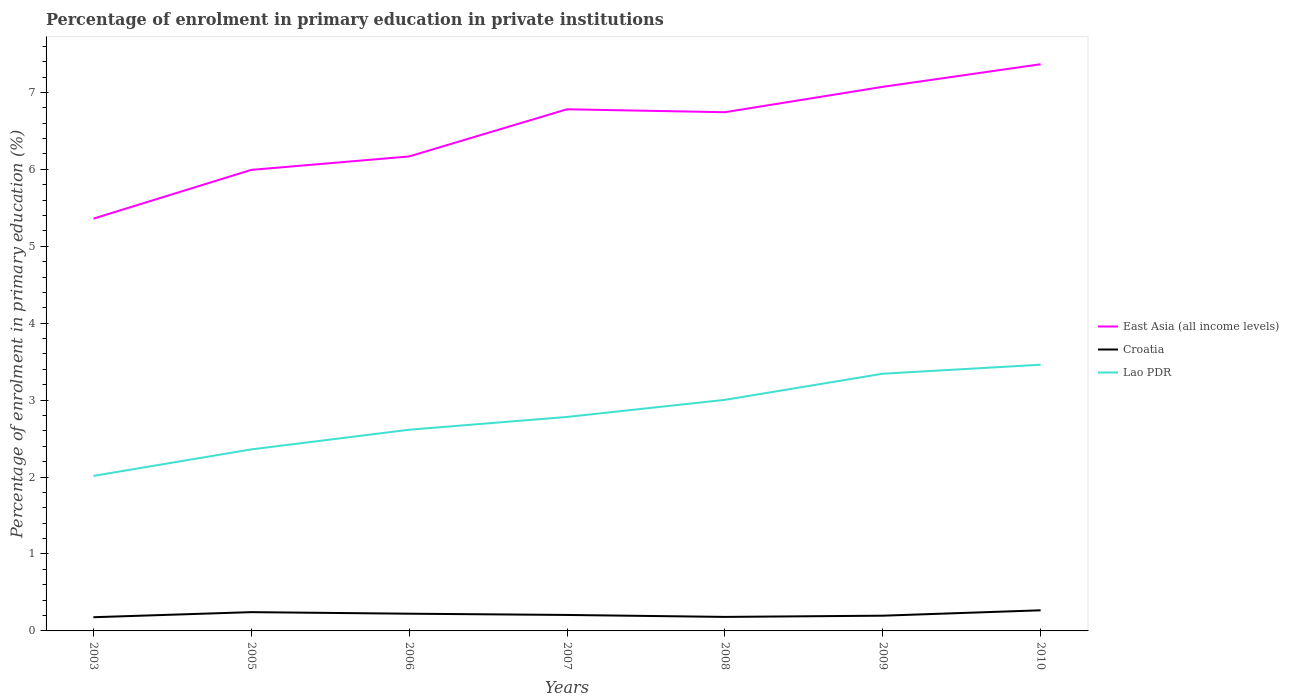How many different coloured lines are there?
Ensure brevity in your answer.  3. Is the number of lines equal to the number of legend labels?
Your answer should be very brief. Yes. Across all years, what is the maximum percentage of enrolment in primary education in East Asia (all income levels)?
Offer a terse response. 5.36. In which year was the percentage of enrolment in primary education in Lao PDR maximum?
Your response must be concise. 2003. What is the total percentage of enrolment in primary education in Croatia in the graph?
Provide a short and direct response. -0. What is the difference between the highest and the second highest percentage of enrolment in primary education in Croatia?
Your answer should be compact. 0.09. How many years are there in the graph?
Provide a succinct answer. 7. Does the graph contain any zero values?
Offer a very short reply. No. Does the graph contain grids?
Your answer should be compact. No. Where does the legend appear in the graph?
Provide a succinct answer. Center right. How are the legend labels stacked?
Your answer should be compact. Vertical. What is the title of the graph?
Offer a terse response. Percentage of enrolment in primary education in private institutions. Does "Middle income" appear as one of the legend labels in the graph?
Give a very brief answer. No. What is the label or title of the Y-axis?
Your response must be concise. Percentage of enrolment in primary education (%). What is the Percentage of enrolment in primary education (%) in East Asia (all income levels) in 2003?
Give a very brief answer. 5.36. What is the Percentage of enrolment in primary education (%) in Croatia in 2003?
Provide a succinct answer. 0.18. What is the Percentage of enrolment in primary education (%) in Lao PDR in 2003?
Your response must be concise. 2.02. What is the Percentage of enrolment in primary education (%) of East Asia (all income levels) in 2005?
Your response must be concise. 5.99. What is the Percentage of enrolment in primary education (%) of Croatia in 2005?
Ensure brevity in your answer.  0.24. What is the Percentage of enrolment in primary education (%) of Lao PDR in 2005?
Give a very brief answer. 2.36. What is the Percentage of enrolment in primary education (%) in East Asia (all income levels) in 2006?
Give a very brief answer. 6.17. What is the Percentage of enrolment in primary education (%) in Croatia in 2006?
Offer a very short reply. 0.22. What is the Percentage of enrolment in primary education (%) in Lao PDR in 2006?
Offer a terse response. 2.62. What is the Percentage of enrolment in primary education (%) of East Asia (all income levels) in 2007?
Keep it short and to the point. 6.78. What is the Percentage of enrolment in primary education (%) of Croatia in 2007?
Provide a succinct answer. 0.21. What is the Percentage of enrolment in primary education (%) of Lao PDR in 2007?
Ensure brevity in your answer.  2.78. What is the Percentage of enrolment in primary education (%) of East Asia (all income levels) in 2008?
Provide a short and direct response. 6.74. What is the Percentage of enrolment in primary education (%) in Croatia in 2008?
Your answer should be compact. 0.18. What is the Percentage of enrolment in primary education (%) in Lao PDR in 2008?
Offer a very short reply. 3. What is the Percentage of enrolment in primary education (%) of East Asia (all income levels) in 2009?
Your answer should be very brief. 7.07. What is the Percentage of enrolment in primary education (%) of Croatia in 2009?
Offer a very short reply. 0.2. What is the Percentage of enrolment in primary education (%) of Lao PDR in 2009?
Make the answer very short. 3.34. What is the Percentage of enrolment in primary education (%) of East Asia (all income levels) in 2010?
Ensure brevity in your answer.  7.37. What is the Percentage of enrolment in primary education (%) of Croatia in 2010?
Provide a short and direct response. 0.27. What is the Percentage of enrolment in primary education (%) of Lao PDR in 2010?
Make the answer very short. 3.46. Across all years, what is the maximum Percentage of enrolment in primary education (%) in East Asia (all income levels)?
Your answer should be very brief. 7.37. Across all years, what is the maximum Percentage of enrolment in primary education (%) of Croatia?
Ensure brevity in your answer.  0.27. Across all years, what is the maximum Percentage of enrolment in primary education (%) in Lao PDR?
Your answer should be compact. 3.46. Across all years, what is the minimum Percentage of enrolment in primary education (%) of East Asia (all income levels)?
Offer a terse response. 5.36. Across all years, what is the minimum Percentage of enrolment in primary education (%) in Croatia?
Provide a short and direct response. 0.18. Across all years, what is the minimum Percentage of enrolment in primary education (%) in Lao PDR?
Ensure brevity in your answer.  2.02. What is the total Percentage of enrolment in primary education (%) in East Asia (all income levels) in the graph?
Your answer should be very brief. 45.48. What is the total Percentage of enrolment in primary education (%) of Croatia in the graph?
Provide a short and direct response. 1.5. What is the total Percentage of enrolment in primary education (%) of Lao PDR in the graph?
Provide a succinct answer. 19.58. What is the difference between the Percentage of enrolment in primary education (%) of East Asia (all income levels) in 2003 and that in 2005?
Provide a short and direct response. -0.63. What is the difference between the Percentage of enrolment in primary education (%) in Croatia in 2003 and that in 2005?
Your answer should be compact. -0.07. What is the difference between the Percentage of enrolment in primary education (%) in Lao PDR in 2003 and that in 2005?
Your response must be concise. -0.34. What is the difference between the Percentage of enrolment in primary education (%) of East Asia (all income levels) in 2003 and that in 2006?
Provide a succinct answer. -0.81. What is the difference between the Percentage of enrolment in primary education (%) of Croatia in 2003 and that in 2006?
Provide a short and direct response. -0.05. What is the difference between the Percentage of enrolment in primary education (%) in Lao PDR in 2003 and that in 2006?
Your response must be concise. -0.6. What is the difference between the Percentage of enrolment in primary education (%) in East Asia (all income levels) in 2003 and that in 2007?
Keep it short and to the point. -1.42. What is the difference between the Percentage of enrolment in primary education (%) of Croatia in 2003 and that in 2007?
Provide a succinct answer. -0.03. What is the difference between the Percentage of enrolment in primary education (%) in Lao PDR in 2003 and that in 2007?
Your response must be concise. -0.77. What is the difference between the Percentage of enrolment in primary education (%) of East Asia (all income levels) in 2003 and that in 2008?
Keep it short and to the point. -1.38. What is the difference between the Percentage of enrolment in primary education (%) in Croatia in 2003 and that in 2008?
Keep it short and to the point. -0. What is the difference between the Percentage of enrolment in primary education (%) in Lao PDR in 2003 and that in 2008?
Offer a very short reply. -0.99. What is the difference between the Percentage of enrolment in primary education (%) in East Asia (all income levels) in 2003 and that in 2009?
Provide a short and direct response. -1.71. What is the difference between the Percentage of enrolment in primary education (%) in Croatia in 2003 and that in 2009?
Make the answer very short. -0.02. What is the difference between the Percentage of enrolment in primary education (%) in Lao PDR in 2003 and that in 2009?
Your answer should be compact. -1.33. What is the difference between the Percentage of enrolment in primary education (%) of East Asia (all income levels) in 2003 and that in 2010?
Make the answer very short. -2.01. What is the difference between the Percentage of enrolment in primary education (%) in Croatia in 2003 and that in 2010?
Provide a short and direct response. -0.09. What is the difference between the Percentage of enrolment in primary education (%) of Lao PDR in 2003 and that in 2010?
Ensure brevity in your answer.  -1.45. What is the difference between the Percentage of enrolment in primary education (%) in East Asia (all income levels) in 2005 and that in 2006?
Offer a very short reply. -0.17. What is the difference between the Percentage of enrolment in primary education (%) of Croatia in 2005 and that in 2006?
Your response must be concise. 0.02. What is the difference between the Percentage of enrolment in primary education (%) in Lao PDR in 2005 and that in 2006?
Give a very brief answer. -0.26. What is the difference between the Percentage of enrolment in primary education (%) of East Asia (all income levels) in 2005 and that in 2007?
Your response must be concise. -0.79. What is the difference between the Percentage of enrolment in primary education (%) of Croatia in 2005 and that in 2007?
Provide a short and direct response. 0.04. What is the difference between the Percentage of enrolment in primary education (%) of Lao PDR in 2005 and that in 2007?
Your answer should be very brief. -0.42. What is the difference between the Percentage of enrolment in primary education (%) of East Asia (all income levels) in 2005 and that in 2008?
Your response must be concise. -0.75. What is the difference between the Percentage of enrolment in primary education (%) in Croatia in 2005 and that in 2008?
Provide a short and direct response. 0.06. What is the difference between the Percentage of enrolment in primary education (%) in Lao PDR in 2005 and that in 2008?
Your response must be concise. -0.64. What is the difference between the Percentage of enrolment in primary education (%) of East Asia (all income levels) in 2005 and that in 2009?
Offer a very short reply. -1.08. What is the difference between the Percentage of enrolment in primary education (%) in Croatia in 2005 and that in 2009?
Offer a very short reply. 0.05. What is the difference between the Percentage of enrolment in primary education (%) in Lao PDR in 2005 and that in 2009?
Offer a very short reply. -0.98. What is the difference between the Percentage of enrolment in primary education (%) of East Asia (all income levels) in 2005 and that in 2010?
Offer a very short reply. -1.37. What is the difference between the Percentage of enrolment in primary education (%) in Croatia in 2005 and that in 2010?
Make the answer very short. -0.02. What is the difference between the Percentage of enrolment in primary education (%) of Lao PDR in 2005 and that in 2010?
Your answer should be very brief. -1.1. What is the difference between the Percentage of enrolment in primary education (%) of East Asia (all income levels) in 2006 and that in 2007?
Offer a very short reply. -0.61. What is the difference between the Percentage of enrolment in primary education (%) in Croatia in 2006 and that in 2007?
Give a very brief answer. 0.02. What is the difference between the Percentage of enrolment in primary education (%) of Lao PDR in 2006 and that in 2007?
Provide a short and direct response. -0.17. What is the difference between the Percentage of enrolment in primary education (%) in East Asia (all income levels) in 2006 and that in 2008?
Offer a terse response. -0.57. What is the difference between the Percentage of enrolment in primary education (%) in Croatia in 2006 and that in 2008?
Provide a succinct answer. 0.04. What is the difference between the Percentage of enrolment in primary education (%) of Lao PDR in 2006 and that in 2008?
Offer a terse response. -0.39. What is the difference between the Percentage of enrolment in primary education (%) of East Asia (all income levels) in 2006 and that in 2009?
Make the answer very short. -0.91. What is the difference between the Percentage of enrolment in primary education (%) of Croatia in 2006 and that in 2009?
Your answer should be compact. 0.03. What is the difference between the Percentage of enrolment in primary education (%) in Lao PDR in 2006 and that in 2009?
Offer a very short reply. -0.73. What is the difference between the Percentage of enrolment in primary education (%) in East Asia (all income levels) in 2006 and that in 2010?
Give a very brief answer. -1.2. What is the difference between the Percentage of enrolment in primary education (%) in Croatia in 2006 and that in 2010?
Make the answer very short. -0.04. What is the difference between the Percentage of enrolment in primary education (%) in Lao PDR in 2006 and that in 2010?
Offer a terse response. -0.84. What is the difference between the Percentage of enrolment in primary education (%) of East Asia (all income levels) in 2007 and that in 2008?
Your answer should be very brief. 0.04. What is the difference between the Percentage of enrolment in primary education (%) of Croatia in 2007 and that in 2008?
Offer a terse response. 0.03. What is the difference between the Percentage of enrolment in primary education (%) of Lao PDR in 2007 and that in 2008?
Your answer should be very brief. -0.22. What is the difference between the Percentage of enrolment in primary education (%) of East Asia (all income levels) in 2007 and that in 2009?
Offer a terse response. -0.29. What is the difference between the Percentage of enrolment in primary education (%) of Croatia in 2007 and that in 2009?
Your response must be concise. 0.01. What is the difference between the Percentage of enrolment in primary education (%) in Lao PDR in 2007 and that in 2009?
Your answer should be very brief. -0.56. What is the difference between the Percentage of enrolment in primary education (%) of East Asia (all income levels) in 2007 and that in 2010?
Ensure brevity in your answer.  -0.59. What is the difference between the Percentage of enrolment in primary education (%) of Croatia in 2007 and that in 2010?
Ensure brevity in your answer.  -0.06. What is the difference between the Percentage of enrolment in primary education (%) of Lao PDR in 2007 and that in 2010?
Ensure brevity in your answer.  -0.68. What is the difference between the Percentage of enrolment in primary education (%) in East Asia (all income levels) in 2008 and that in 2009?
Give a very brief answer. -0.33. What is the difference between the Percentage of enrolment in primary education (%) in Croatia in 2008 and that in 2009?
Make the answer very short. -0.02. What is the difference between the Percentage of enrolment in primary education (%) in Lao PDR in 2008 and that in 2009?
Offer a very short reply. -0.34. What is the difference between the Percentage of enrolment in primary education (%) of East Asia (all income levels) in 2008 and that in 2010?
Provide a short and direct response. -0.62. What is the difference between the Percentage of enrolment in primary education (%) of Croatia in 2008 and that in 2010?
Give a very brief answer. -0.09. What is the difference between the Percentage of enrolment in primary education (%) of Lao PDR in 2008 and that in 2010?
Ensure brevity in your answer.  -0.46. What is the difference between the Percentage of enrolment in primary education (%) of East Asia (all income levels) in 2009 and that in 2010?
Your answer should be very brief. -0.29. What is the difference between the Percentage of enrolment in primary education (%) in Croatia in 2009 and that in 2010?
Ensure brevity in your answer.  -0.07. What is the difference between the Percentage of enrolment in primary education (%) of Lao PDR in 2009 and that in 2010?
Make the answer very short. -0.12. What is the difference between the Percentage of enrolment in primary education (%) in East Asia (all income levels) in 2003 and the Percentage of enrolment in primary education (%) in Croatia in 2005?
Your answer should be compact. 5.12. What is the difference between the Percentage of enrolment in primary education (%) in East Asia (all income levels) in 2003 and the Percentage of enrolment in primary education (%) in Lao PDR in 2005?
Provide a short and direct response. 3. What is the difference between the Percentage of enrolment in primary education (%) in Croatia in 2003 and the Percentage of enrolment in primary education (%) in Lao PDR in 2005?
Make the answer very short. -2.18. What is the difference between the Percentage of enrolment in primary education (%) of East Asia (all income levels) in 2003 and the Percentage of enrolment in primary education (%) of Croatia in 2006?
Make the answer very short. 5.14. What is the difference between the Percentage of enrolment in primary education (%) in East Asia (all income levels) in 2003 and the Percentage of enrolment in primary education (%) in Lao PDR in 2006?
Your answer should be very brief. 2.74. What is the difference between the Percentage of enrolment in primary education (%) of Croatia in 2003 and the Percentage of enrolment in primary education (%) of Lao PDR in 2006?
Keep it short and to the point. -2.44. What is the difference between the Percentage of enrolment in primary education (%) of East Asia (all income levels) in 2003 and the Percentage of enrolment in primary education (%) of Croatia in 2007?
Offer a terse response. 5.15. What is the difference between the Percentage of enrolment in primary education (%) in East Asia (all income levels) in 2003 and the Percentage of enrolment in primary education (%) in Lao PDR in 2007?
Your answer should be very brief. 2.58. What is the difference between the Percentage of enrolment in primary education (%) in Croatia in 2003 and the Percentage of enrolment in primary education (%) in Lao PDR in 2007?
Offer a very short reply. -2.6. What is the difference between the Percentage of enrolment in primary education (%) of East Asia (all income levels) in 2003 and the Percentage of enrolment in primary education (%) of Croatia in 2008?
Give a very brief answer. 5.18. What is the difference between the Percentage of enrolment in primary education (%) in East Asia (all income levels) in 2003 and the Percentage of enrolment in primary education (%) in Lao PDR in 2008?
Make the answer very short. 2.36. What is the difference between the Percentage of enrolment in primary education (%) in Croatia in 2003 and the Percentage of enrolment in primary education (%) in Lao PDR in 2008?
Keep it short and to the point. -2.83. What is the difference between the Percentage of enrolment in primary education (%) in East Asia (all income levels) in 2003 and the Percentage of enrolment in primary education (%) in Croatia in 2009?
Give a very brief answer. 5.16. What is the difference between the Percentage of enrolment in primary education (%) of East Asia (all income levels) in 2003 and the Percentage of enrolment in primary education (%) of Lao PDR in 2009?
Make the answer very short. 2.02. What is the difference between the Percentage of enrolment in primary education (%) in Croatia in 2003 and the Percentage of enrolment in primary education (%) in Lao PDR in 2009?
Offer a terse response. -3.17. What is the difference between the Percentage of enrolment in primary education (%) in East Asia (all income levels) in 2003 and the Percentage of enrolment in primary education (%) in Croatia in 2010?
Ensure brevity in your answer.  5.09. What is the difference between the Percentage of enrolment in primary education (%) in East Asia (all income levels) in 2003 and the Percentage of enrolment in primary education (%) in Lao PDR in 2010?
Your answer should be very brief. 1.9. What is the difference between the Percentage of enrolment in primary education (%) in Croatia in 2003 and the Percentage of enrolment in primary education (%) in Lao PDR in 2010?
Give a very brief answer. -3.28. What is the difference between the Percentage of enrolment in primary education (%) of East Asia (all income levels) in 2005 and the Percentage of enrolment in primary education (%) of Croatia in 2006?
Offer a terse response. 5.77. What is the difference between the Percentage of enrolment in primary education (%) of East Asia (all income levels) in 2005 and the Percentage of enrolment in primary education (%) of Lao PDR in 2006?
Provide a succinct answer. 3.38. What is the difference between the Percentage of enrolment in primary education (%) of Croatia in 2005 and the Percentage of enrolment in primary education (%) of Lao PDR in 2006?
Keep it short and to the point. -2.37. What is the difference between the Percentage of enrolment in primary education (%) in East Asia (all income levels) in 2005 and the Percentage of enrolment in primary education (%) in Croatia in 2007?
Your answer should be compact. 5.79. What is the difference between the Percentage of enrolment in primary education (%) of East Asia (all income levels) in 2005 and the Percentage of enrolment in primary education (%) of Lao PDR in 2007?
Make the answer very short. 3.21. What is the difference between the Percentage of enrolment in primary education (%) in Croatia in 2005 and the Percentage of enrolment in primary education (%) in Lao PDR in 2007?
Give a very brief answer. -2.54. What is the difference between the Percentage of enrolment in primary education (%) of East Asia (all income levels) in 2005 and the Percentage of enrolment in primary education (%) of Croatia in 2008?
Your response must be concise. 5.81. What is the difference between the Percentage of enrolment in primary education (%) in East Asia (all income levels) in 2005 and the Percentage of enrolment in primary education (%) in Lao PDR in 2008?
Offer a very short reply. 2.99. What is the difference between the Percentage of enrolment in primary education (%) in Croatia in 2005 and the Percentage of enrolment in primary education (%) in Lao PDR in 2008?
Offer a very short reply. -2.76. What is the difference between the Percentage of enrolment in primary education (%) of East Asia (all income levels) in 2005 and the Percentage of enrolment in primary education (%) of Croatia in 2009?
Make the answer very short. 5.8. What is the difference between the Percentage of enrolment in primary education (%) of East Asia (all income levels) in 2005 and the Percentage of enrolment in primary education (%) of Lao PDR in 2009?
Your response must be concise. 2.65. What is the difference between the Percentage of enrolment in primary education (%) in Croatia in 2005 and the Percentage of enrolment in primary education (%) in Lao PDR in 2009?
Make the answer very short. -3.1. What is the difference between the Percentage of enrolment in primary education (%) of East Asia (all income levels) in 2005 and the Percentage of enrolment in primary education (%) of Croatia in 2010?
Your answer should be compact. 5.72. What is the difference between the Percentage of enrolment in primary education (%) of East Asia (all income levels) in 2005 and the Percentage of enrolment in primary education (%) of Lao PDR in 2010?
Provide a succinct answer. 2.53. What is the difference between the Percentage of enrolment in primary education (%) in Croatia in 2005 and the Percentage of enrolment in primary education (%) in Lao PDR in 2010?
Ensure brevity in your answer.  -3.22. What is the difference between the Percentage of enrolment in primary education (%) of East Asia (all income levels) in 2006 and the Percentage of enrolment in primary education (%) of Croatia in 2007?
Give a very brief answer. 5.96. What is the difference between the Percentage of enrolment in primary education (%) of East Asia (all income levels) in 2006 and the Percentage of enrolment in primary education (%) of Lao PDR in 2007?
Offer a terse response. 3.39. What is the difference between the Percentage of enrolment in primary education (%) in Croatia in 2006 and the Percentage of enrolment in primary education (%) in Lao PDR in 2007?
Offer a terse response. -2.56. What is the difference between the Percentage of enrolment in primary education (%) of East Asia (all income levels) in 2006 and the Percentage of enrolment in primary education (%) of Croatia in 2008?
Offer a very short reply. 5.99. What is the difference between the Percentage of enrolment in primary education (%) in East Asia (all income levels) in 2006 and the Percentage of enrolment in primary education (%) in Lao PDR in 2008?
Your response must be concise. 3.16. What is the difference between the Percentage of enrolment in primary education (%) of Croatia in 2006 and the Percentage of enrolment in primary education (%) of Lao PDR in 2008?
Your answer should be compact. -2.78. What is the difference between the Percentage of enrolment in primary education (%) in East Asia (all income levels) in 2006 and the Percentage of enrolment in primary education (%) in Croatia in 2009?
Your response must be concise. 5.97. What is the difference between the Percentage of enrolment in primary education (%) of East Asia (all income levels) in 2006 and the Percentage of enrolment in primary education (%) of Lao PDR in 2009?
Make the answer very short. 2.82. What is the difference between the Percentage of enrolment in primary education (%) in Croatia in 2006 and the Percentage of enrolment in primary education (%) in Lao PDR in 2009?
Make the answer very short. -3.12. What is the difference between the Percentage of enrolment in primary education (%) in East Asia (all income levels) in 2006 and the Percentage of enrolment in primary education (%) in Croatia in 2010?
Keep it short and to the point. 5.9. What is the difference between the Percentage of enrolment in primary education (%) of East Asia (all income levels) in 2006 and the Percentage of enrolment in primary education (%) of Lao PDR in 2010?
Ensure brevity in your answer.  2.71. What is the difference between the Percentage of enrolment in primary education (%) of Croatia in 2006 and the Percentage of enrolment in primary education (%) of Lao PDR in 2010?
Make the answer very short. -3.24. What is the difference between the Percentage of enrolment in primary education (%) of East Asia (all income levels) in 2007 and the Percentage of enrolment in primary education (%) of Croatia in 2008?
Your response must be concise. 6.6. What is the difference between the Percentage of enrolment in primary education (%) of East Asia (all income levels) in 2007 and the Percentage of enrolment in primary education (%) of Lao PDR in 2008?
Offer a terse response. 3.78. What is the difference between the Percentage of enrolment in primary education (%) in Croatia in 2007 and the Percentage of enrolment in primary education (%) in Lao PDR in 2008?
Make the answer very short. -2.8. What is the difference between the Percentage of enrolment in primary education (%) in East Asia (all income levels) in 2007 and the Percentage of enrolment in primary education (%) in Croatia in 2009?
Offer a terse response. 6.58. What is the difference between the Percentage of enrolment in primary education (%) of East Asia (all income levels) in 2007 and the Percentage of enrolment in primary education (%) of Lao PDR in 2009?
Ensure brevity in your answer.  3.44. What is the difference between the Percentage of enrolment in primary education (%) in Croatia in 2007 and the Percentage of enrolment in primary education (%) in Lao PDR in 2009?
Your response must be concise. -3.14. What is the difference between the Percentage of enrolment in primary education (%) in East Asia (all income levels) in 2007 and the Percentage of enrolment in primary education (%) in Croatia in 2010?
Your answer should be compact. 6.51. What is the difference between the Percentage of enrolment in primary education (%) of East Asia (all income levels) in 2007 and the Percentage of enrolment in primary education (%) of Lao PDR in 2010?
Keep it short and to the point. 3.32. What is the difference between the Percentage of enrolment in primary education (%) in Croatia in 2007 and the Percentage of enrolment in primary education (%) in Lao PDR in 2010?
Give a very brief answer. -3.25. What is the difference between the Percentage of enrolment in primary education (%) in East Asia (all income levels) in 2008 and the Percentage of enrolment in primary education (%) in Croatia in 2009?
Your answer should be compact. 6.54. What is the difference between the Percentage of enrolment in primary education (%) of East Asia (all income levels) in 2008 and the Percentage of enrolment in primary education (%) of Lao PDR in 2009?
Ensure brevity in your answer.  3.4. What is the difference between the Percentage of enrolment in primary education (%) of Croatia in 2008 and the Percentage of enrolment in primary education (%) of Lao PDR in 2009?
Ensure brevity in your answer.  -3.16. What is the difference between the Percentage of enrolment in primary education (%) of East Asia (all income levels) in 2008 and the Percentage of enrolment in primary education (%) of Croatia in 2010?
Offer a very short reply. 6.47. What is the difference between the Percentage of enrolment in primary education (%) of East Asia (all income levels) in 2008 and the Percentage of enrolment in primary education (%) of Lao PDR in 2010?
Ensure brevity in your answer.  3.28. What is the difference between the Percentage of enrolment in primary education (%) in Croatia in 2008 and the Percentage of enrolment in primary education (%) in Lao PDR in 2010?
Keep it short and to the point. -3.28. What is the difference between the Percentage of enrolment in primary education (%) of East Asia (all income levels) in 2009 and the Percentage of enrolment in primary education (%) of Croatia in 2010?
Make the answer very short. 6.8. What is the difference between the Percentage of enrolment in primary education (%) in East Asia (all income levels) in 2009 and the Percentage of enrolment in primary education (%) in Lao PDR in 2010?
Provide a short and direct response. 3.61. What is the difference between the Percentage of enrolment in primary education (%) of Croatia in 2009 and the Percentage of enrolment in primary education (%) of Lao PDR in 2010?
Offer a very short reply. -3.26. What is the average Percentage of enrolment in primary education (%) in East Asia (all income levels) per year?
Your answer should be compact. 6.5. What is the average Percentage of enrolment in primary education (%) of Croatia per year?
Your response must be concise. 0.21. What is the average Percentage of enrolment in primary education (%) in Lao PDR per year?
Provide a short and direct response. 2.8. In the year 2003, what is the difference between the Percentage of enrolment in primary education (%) in East Asia (all income levels) and Percentage of enrolment in primary education (%) in Croatia?
Your response must be concise. 5.18. In the year 2003, what is the difference between the Percentage of enrolment in primary education (%) in East Asia (all income levels) and Percentage of enrolment in primary education (%) in Lao PDR?
Provide a succinct answer. 3.34. In the year 2003, what is the difference between the Percentage of enrolment in primary education (%) of Croatia and Percentage of enrolment in primary education (%) of Lao PDR?
Keep it short and to the point. -1.84. In the year 2005, what is the difference between the Percentage of enrolment in primary education (%) in East Asia (all income levels) and Percentage of enrolment in primary education (%) in Croatia?
Your answer should be very brief. 5.75. In the year 2005, what is the difference between the Percentage of enrolment in primary education (%) in East Asia (all income levels) and Percentage of enrolment in primary education (%) in Lao PDR?
Your answer should be very brief. 3.63. In the year 2005, what is the difference between the Percentage of enrolment in primary education (%) in Croatia and Percentage of enrolment in primary education (%) in Lao PDR?
Offer a terse response. -2.12. In the year 2006, what is the difference between the Percentage of enrolment in primary education (%) of East Asia (all income levels) and Percentage of enrolment in primary education (%) of Croatia?
Give a very brief answer. 5.94. In the year 2006, what is the difference between the Percentage of enrolment in primary education (%) of East Asia (all income levels) and Percentage of enrolment in primary education (%) of Lao PDR?
Offer a very short reply. 3.55. In the year 2006, what is the difference between the Percentage of enrolment in primary education (%) in Croatia and Percentage of enrolment in primary education (%) in Lao PDR?
Provide a short and direct response. -2.39. In the year 2007, what is the difference between the Percentage of enrolment in primary education (%) of East Asia (all income levels) and Percentage of enrolment in primary education (%) of Croatia?
Your answer should be very brief. 6.57. In the year 2007, what is the difference between the Percentage of enrolment in primary education (%) of East Asia (all income levels) and Percentage of enrolment in primary education (%) of Lao PDR?
Offer a very short reply. 4. In the year 2007, what is the difference between the Percentage of enrolment in primary education (%) of Croatia and Percentage of enrolment in primary education (%) of Lao PDR?
Your response must be concise. -2.57. In the year 2008, what is the difference between the Percentage of enrolment in primary education (%) of East Asia (all income levels) and Percentage of enrolment in primary education (%) of Croatia?
Make the answer very short. 6.56. In the year 2008, what is the difference between the Percentage of enrolment in primary education (%) in East Asia (all income levels) and Percentage of enrolment in primary education (%) in Lao PDR?
Provide a succinct answer. 3.74. In the year 2008, what is the difference between the Percentage of enrolment in primary education (%) in Croatia and Percentage of enrolment in primary education (%) in Lao PDR?
Your response must be concise. -2.82. In the year 2009, what is the difference between the Percentage of enrolment in primary education (%) of East Asia (all income levels) and Percentage of enrolment in primary education (%) of Croatia?
Your answer should be very brief. 6.87. In the year 2009, what is the difference between the Percentage of enrolment in primary education (%) of East Asia (all income levels) and Percentage of enrolment in primary education (%) of Lao PDR?
Give a very brief answer. 3.73. In the year 2009, what is the difference between the Percentage of enrolment in primary education (%) of Croatia and Percentage of enrolment in primary education (%) of Lao PDR?
Make the answer very short. -3.15. In the year 2010, what is the difference between the Percentage of enrolment in primary education (%) of East Asia (all income levels) and Percentage of enrolment in primary education (%) of Croatia?
Your answer should be compact. 7.1. In the year 2010, what is the difference between the Percentage of enrolment in primary education (%) of East Asia (all income levels) and Percentage of enrolment in primary education (%) of Lao PDR?
Offer a very short reply. 3.91. In the year 2010, what is the difference between the Percentage of enrolment in primary education (%) of Croatia and Percentage of enrolment in primary education (%) of Lao PDR?
Your response must be concise. -3.19. What is the ratio of the Percentage of enrolment in primary education (%) in East Asia (all income levels) in 2003 to that in 2005?
Make the answer very short. 0.89. What is the ratio of the Percentage of enrolment in primary education (%) in Croatia in 2003 to that in 2005?
Offer a very short reply. 0.73. What is the ratio of the Percentage of enrolment in primary education (%) in Lao PDR in 2003 to that in 2005?
Keep it short and to the point. 0.85. What is the ratio of the Percentage of enrolment in primary education (%) of East Asia (all income levels) in 2003 to that in 2006?
Your answer should be compact. 0.87. What is the ratio of the Percentage of enrolment in primary education (%) of Croatia in 2003 to that in 2006?
Make the answer very short. 0.8. What is the ratio of the Percentage of enrolment in primary education (%) in Lao PDR in 2003 to that in 2006?
Your answer should be compact. 0.77. What is the ratio of the Percentage of enrolment in primary education (%) of East Asia (all income levels) in 2003 to that in 2007?
Ensure brevity in your answer.  0.79. What is the ratio of the Percentage of enrolment in primary education (%) of Croatia in 2003 to that in 2007?
Provide a succinct answer. 0.86. What is the ratio of the Percentage of enrolment in primary education (%) in Lao PDR in 2003 to that in 2007?
Your answer should be very brief. 0.72. What is the ratio of the Percentage of enrolment in primary education (%) in East Asia (all income levels) in 2003 to that in 2008?
Keep it short and to the point. 0.79. What is the ratio of the Percentage of enrolment in primary education (%) in Croatia in 2003 to that in 2008?
Provide a short and direct response. 0.98. What is the ratio of the Percentage of enrolment in primary education (%) in Lao PDR in 2003 to that in 2008?
Give a very brief answer. 0.67. What is the ratio of the Percentage of enrolment in primary education (%) in East Asia (all income levels) in 2003 to that in 2009?
Give a very brief answer. 0.76. What is the ratio of the Percentage of enrolment in primary education (%) of Croatia in 2003 to that in 2009?
Provide a succinct answer. 0.9. What is the ratio of the Percentage of enrolment in primary education (%) of Lao PDR in 2003 to that in 2009?
Make the answer very short. 0.6. What is the ratio of the Percentage of enrolment in primary education (%) in East Asia (all income levels) in 2003 to that in 2010?
Your answer should be compact. 0.73. What is the ratio of the Percentage of enrolment in primary education (%) of Croatia in 2003 to that in 2010?
Your response must be concise. 0.66. What is the ratio of the Percentage of enrolment in primary education (%) of Lao PDR in 2003 to that in 2010?
Your answer should be very brief. 0.58. What is the ratio of the Percentage of enrolment in primary education (%) of East Asia (all income levels) in 2005 to that in 2006?
Give a very brief answer. 0.97. What is the ratio of the Percentage of enrolment in primary education (%) in Croatia in 2005 to that in 2006?
Make the answer very short. 1.09. What is the ratio of the Percentage of enrolment in primary education (%) of Lao PDR in 2005 to that in 2006?
Offer a very short reply. 0.9. What is the ratio of the Percentage of enrolment in primary education (%) in East Asia (all income levels) in 2005 to that in 2007?
Keep it short and to the point. 0.88. What is the ratio of the Percentage of enrolment in primary education (%) in Croatia in 2005 to that in 2007?
Give a very brief answer. 1.18. What is the ratio of the Percentage of enrolment in primary education (%) of Lao PDR in 2005 to that in 2007?
Your response must be concise. 0.85. What is the ratio of the Percentage of enrolment in primary education (%) of East Asia (all income levels) in 2005 to that in 2008?
Your answer should be very brief. 0.89. What is the ratio of the Percentage of enrolment in primary education (%) in Croatia in 2005 to that in 2008?
Offer a very short reply. 1.34. What is the ratio of the Percentage of enrolment in primary education (%) in Lao PDR in 2005 to that in 2008?
Provide a short and direct response. 0.79. What is the ratio of the Percentage of enrolment in primary education (%) in East Asia (all income levels) in 2005 to that in 2009?
Your answer should be compact. 0.85. What is the ratio of the Percentage of enrolment in primary education (%) of Croatia in 2005 to that in 2009?
Offer a terse response. 1.23. What is the ratio of the Percentage of enrolment in primary education (%) in Lao PDR in 2005 to that in 2009?
Provide a short and direct response. 0.71. What is the ratio of the Percentage of enrolment in primary education (%) in East Asia (all income levels) in 2005 to that in 2010?
Your answer should be very brief. 0.81. What is the ratio of the Percentage of enrolment in primary education (%) of Croatia in 2005 to that in 2010?
Your response must be concise. 0.91. What is the ratio of the Percentage of enrolment in primary education (%) in Lao PDR in 2005 to that in 2010?
Your answer should be very brief. 0.68. What is the ratio of the Percentage of enrolment in primary education (%) in East Asia (all income levels) in 2006 to that in 2007?
Make the answer very short. 0.91. What is the ratio of the Percentage of enrolment in primary education (%) of Croatia in 2006 to that in 2007?
Offer a very short reply. 1.08. What is the ratio of the Percentage of enrolment in primary education (%) of Lao PDR in 2006 to that in 2007?
Ensure brevity in your answer.  0.94. What is the ratio of the Percentage of enrolment in primary education (%) of East Asia (all income levels) in 2006 to that in 2008?
Offer a very short reply. 0.91. What is the ratio of the Percentage of enrolment in primary education (%) of Croatia in 2006 to that in 2008?
Keep it short and to the point. 1.23. What is the ratio of the Percentage of enrolment in primary education (%) in Lao PDR in 2006 to that in 2008?
Make the answer very short. 0.87. What is the ratio of the Percentage of enrolment in primary education (%) in East Asia (all income levels) in 2006 to that in 2009?
Make the answer very short. 0.87. What is the ratio of the Percentage of enrolment in primary education (%) in Croatia in 2006 to that in 2009?
Make the answer very short. 1.13. What is the ratio of the Percentage of enrolment in primary education (%) of Lao PDR in 2006 to that in 2009?
Provide a short and direct response. 0.78. What is the ratio of the Percentage of enrolment in primary education (%) in East Asia (all income levels) in 2006 to that in 2010?
Give a very brief answer. 0.84. What is the ratio of the Percentage of enrolment in primary education (%) of Croatia in 2006 to that in 2010?
Offer a terse response. 0.83. What is the ratio of the Percentage of enrolment in primary education (%) in Lao PDR in 2006 to that in 2010?
Give a very brief answer. 0.76. What is the ratio of the Percentage of enrolment in primary education (%) of East Asia (all income levels) in 2007 to that in 2008?
Provide a succinct answer. 1.01. What is the ratio of the Percentage of enrolment in primary education (%) in Croatia in 2007 to that in 2008?
Give a very brief answer. 1.14. What is the ratio of the Percentage of enrolment in primary education (%) of Lao PDR in 2007 to that in 2008?
Make the answer very short. 0.93. What is the ratio of the Percentage of enrolment in primary education (%) in East Asia (all income levels) in 2007 to that in 2009?
Your response must be concise. 0.96. What is the ratio of the Percentage of enrolment in primary education (%) of Croatia in 2007 to that in 2009?
Offer a terse response. 1.05. What is the ratio of the Percentage of enrolment in primary education (%) of Lao PDR in 2007 to that in 2009?
Your answer should be compact. 0.83. What is the ratio of the Percentage of enrolment in primary education (%) in East Asia (all income levels) in 2007 to that in 2010?
Make the answer very short. 0.92. What is the ratio of the Percentage of enrolment in primary education (%) of Croatia in 2007 to that in 2010?
Your answer should be compact. 0.77. What is the ratio of the Percentage of enrolment in primary education (%) in Lao PDR in 2007 to that in 2010?
Provide a succinct answer. 0.8. What is the ratio of the Percentage of enrolment in primary education (%) in East Asia (all income levels) in 2008 to that in 2009?
Make the answer very short. 0.95. What is the ratio of the Percentage of enrolment in primary education (%) of Croatia in 2008 to that in 2009?
Make the answer very short. 0.92. What is the ratio of the Percentage of enrolment in primary education (%) in Lao PDR in 2008 to that in 2009?
Offer a very short reply. 0.9. What is the ratio of the Percentage of enrolment in primary education (%) in East Asia (all income levels) in 2008 to that in 2010?
Give a very brief answer. 0.92. What is the ratio of the Percentage of enrolment in primary education (%) in Croatia in 2008 to that in 2010?
Offer a very short reply. 0.68. What is the ratio of the Percentage of enrolment in primary education (%) in Lao PDR in 2008 to that in 2010?
Your response must be concise. 0.87. What is the ratio of the Percentage of enrolment in primary education (%) in East Asia (all income levels) in 2009 to that in 2010?
Your answer should be compact. 0.96. What is the ratio of the Percentage of enrolment in primary education (%) in Croatia in 2009 to that in 2010?
Your response must be concise. 0.74. What is the ratio of the Percentage of enrolment in primary education (%) of Lao PDR in 2009 to that in 2010?
Your answer should be very brief. 0.97. What is the difference between the highest and the second highest Percentage of enrolment in primary education (%) of East Asia (all income levels)?
Provide a short and direct response. 0.29. What is the difference between the highest and the second highest Percentage of enrolment in primary education (%) of Croatia?
Your response must be concise. 0.02. What is the difference between the highest and the second highest Percentage of enrolment in primary education (%) of Lao PDR?
Offer a terse response. 0.12. What is the difference between the highest and the lowest Percentage of enrolment in primary education (%) in East Asia (all income levels)?
Ensure brevity in your answer.  2.01. What is the difference between the highest and the lowest Percentage of enrolment in primary education (%) of Croatia?
Give a very brief answer. 0.09. What is the difference between the highest and the lowest Percentage of enrolment in primary education (%) of Lao PDR?
Provide a succinct answer. 1.45. 